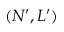Convert formula to latex. <formula><loc_0><loc_0><loc_500><loc_500>( N ^ { \prime } , L ^ { \prime } )</formula> 